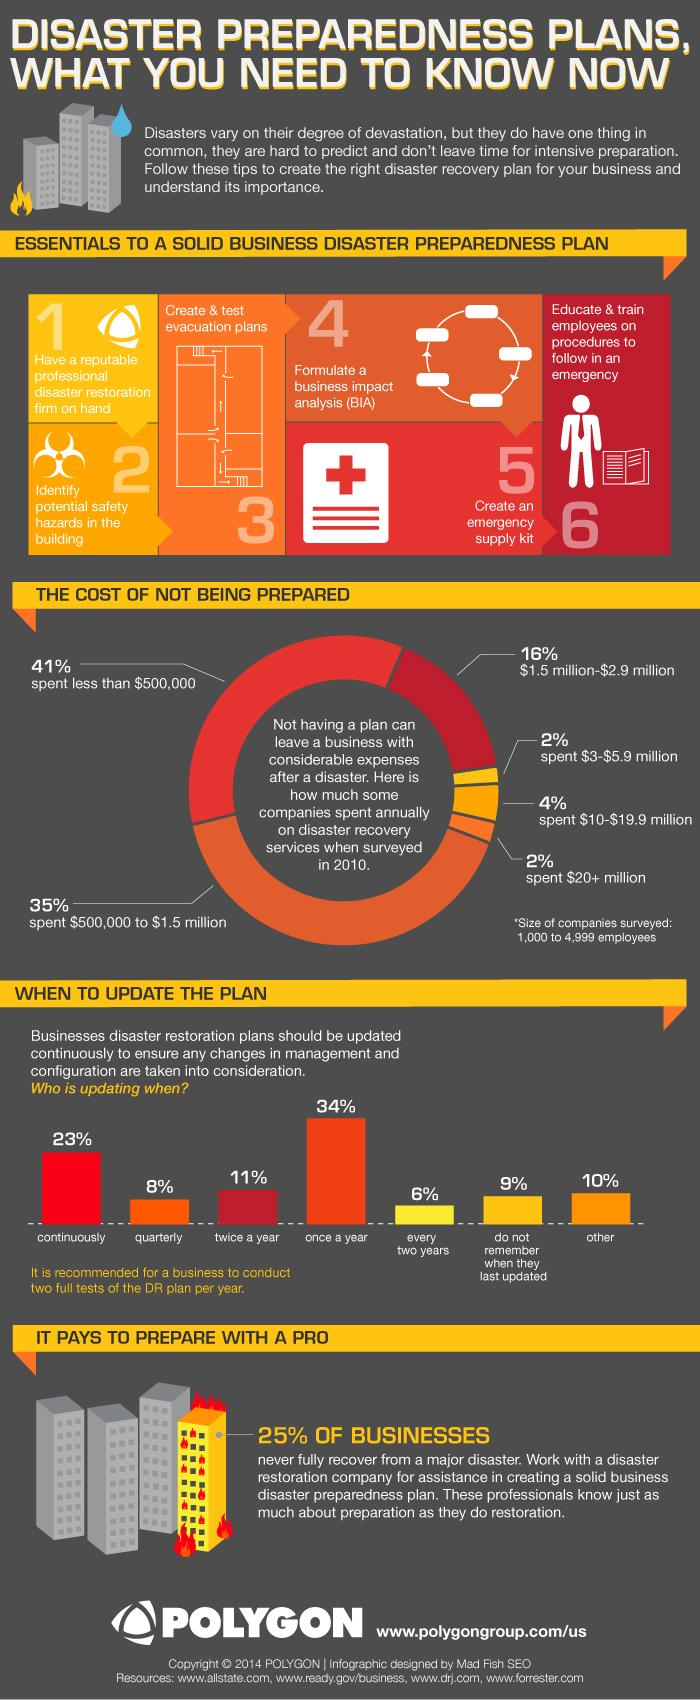Draw attention to some important aspects in this diagram. According to the given information, 41% of companies spent less than half a million dollars on disaster recovery. In the process of developing a disaster preparedness plan, a business impact analysis is typically formulated at Step 4. The third step in creating a disaster preparedness plan is to create and test evacuation plans. According to the given data, 24% of the companies surveyed had to spend $1.5 million or more on disaster recovery. According to the given data, only 6% of companies update their disaster restoration plans every two years. 